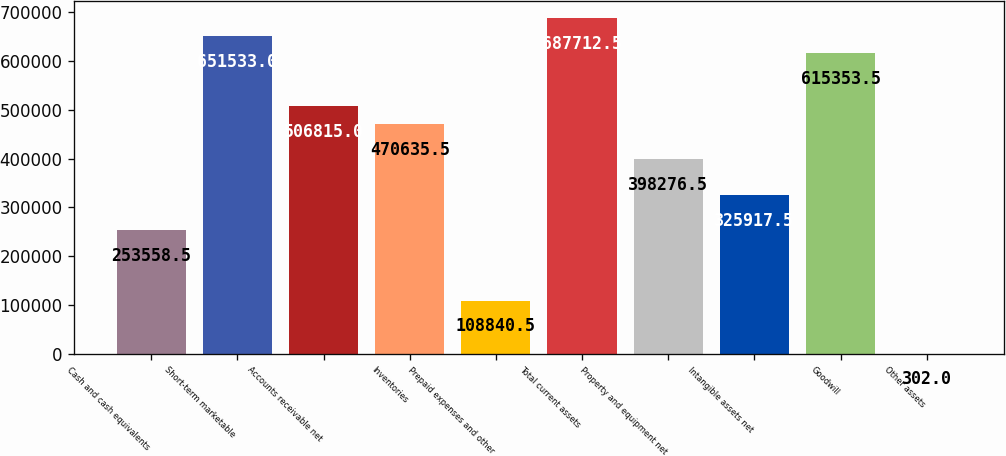Convert chart. <chart><loc_0><loc_0><loc_500><loc_500><bar_chart><fcel>Cash and cash equivalents<fcel>Short-term marketable<fcel>Accounts receivable net<fcel>Inventories<fcel>Prepaid expenses and other<fcel>Total current assets<fcel>Property and equipment net<fcel>Intangible assets net<fcel>Goodwill<fcel>Other assets<nl><fcel>253558<fcel>651533<fcel>506815<fcel>470636<fcel>108840<fcel>687712<fcel>398276<fcel>325918<fcel>615354<fcel>302<nl></chart> 